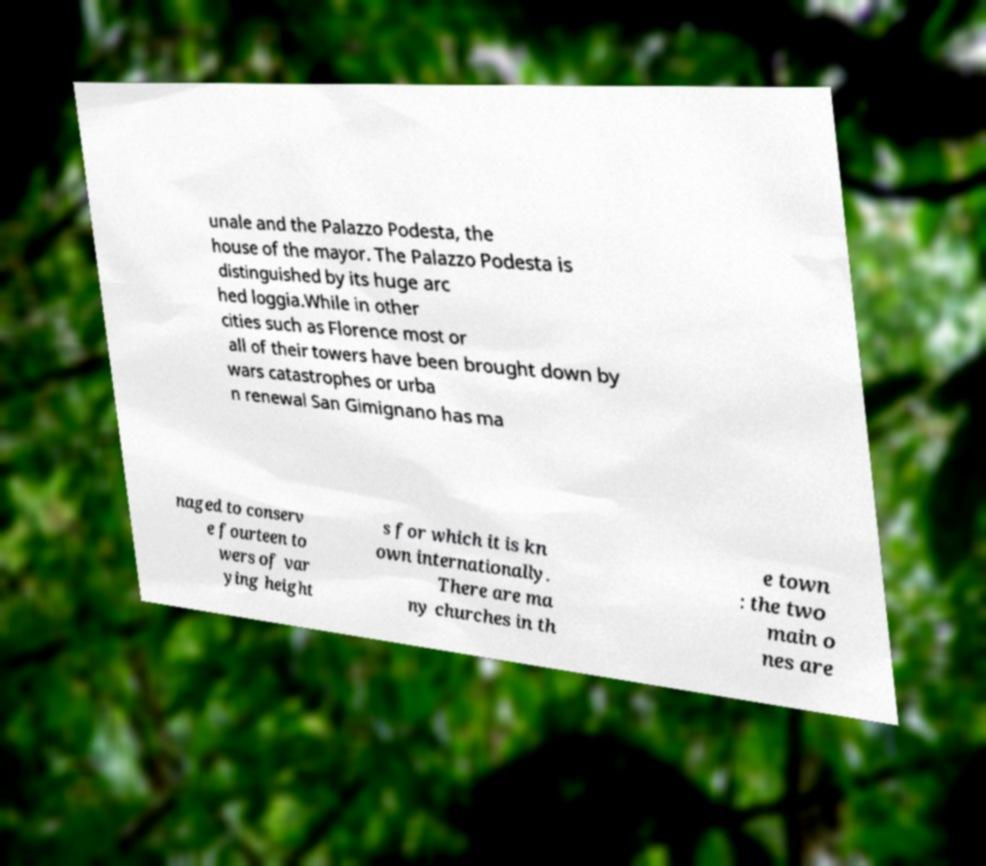What messages or text are displayed in this image? I need them in a readable, typed format. unale and the Palazzo Podesta, the house of the mayor. The Palazzo Podesta is distinguished by its huge arc hed loggia.While in other cities such as Florence most or all of their towers have been brought down by wars catastrophes or urba n renewal San Gimignano has ma naged to conserv e fourteen to wers of var ying height s for which it is kn own internationally. There are ma ny churches in th e town : the two main o nes are 